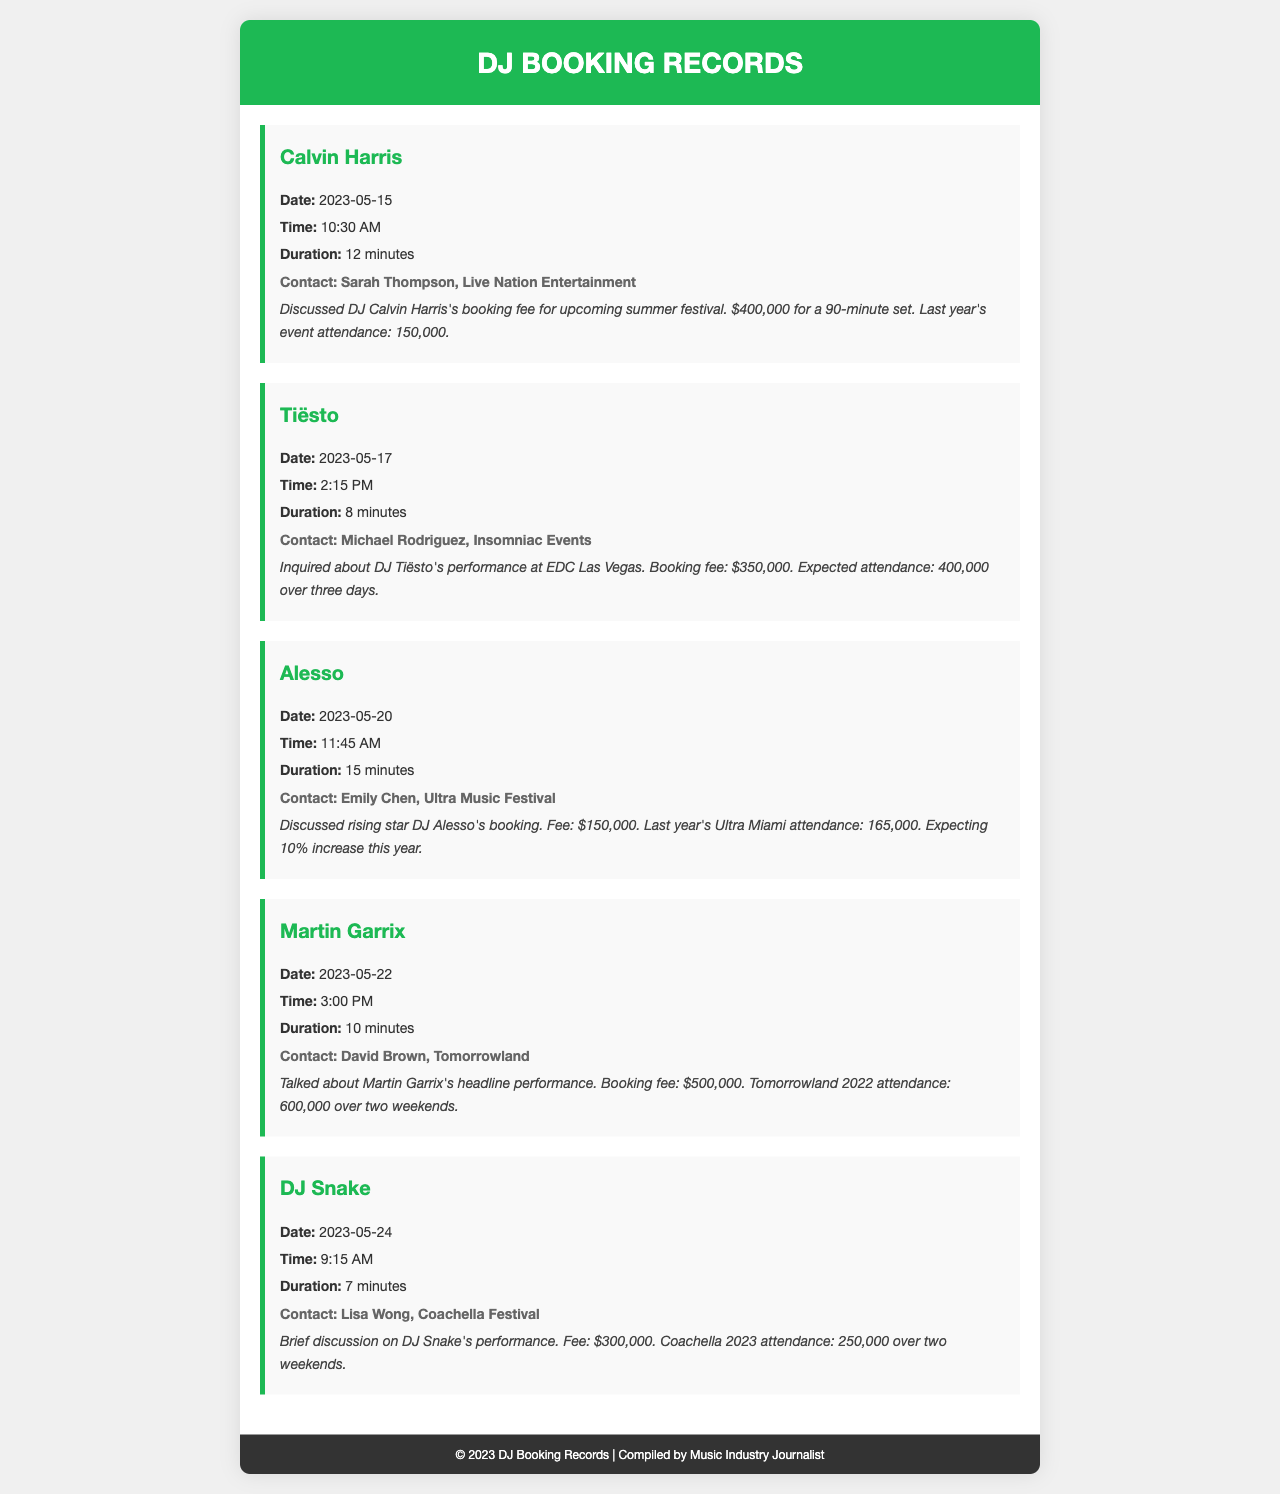What is the booking fee for Calvin Harris? The booking fee for Calvin Harris is mentioned as $400,000 for a 90-minute set.
Answer: $400,000 What is the expected attendance for DJ Tiësto at EDC Las Vegas? The expected attendance for DJ Tiësto at EDC Las Vegas is stated as 400,000 over three days.
Answer: 400,000 Who is the contact for DJ Alesso's booking? The contact for DJ Alesso's booking is Emily Chen from Ultra Music Festival.
Answer: Emily Chen What was the attendance for Tomorrowland 2022? The attendance for Tomorrowland 2022 is reported as 600,000 over two weekends.
Answer: 600,000 Which DJ has the highest booking fee? The DJ with the highest booking fee is Martin Garrix with a fee of $500,000.
Answer: Martin Garrix How long was the call regarding DJ Snake? The call regarding DJ Snake lasted for 7 minutes.
Answer: 7 minutes What is the anticipated increase in attendance for Ultra Miami this year? The anticipated increase in attendance for Ultra Miami this year is 10%.
Answer: 10% Which festival's attendance includes a two-weekend event? The festival that includes a two-weekend event is Coachella with an attendance of 250,000.
Answer: Coachella What is the date of the phone call about Martin Garrix? The date of the phone call about Martin Garrix is 2023-05-22.
Answer: 2023-05-22 